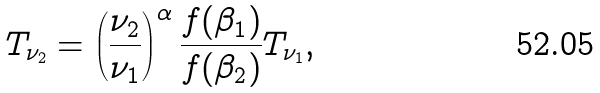Convert formula to latex. <formula><loc_0><loc_0><loc_500><loc_500>T _ { \nu _ { 2 } } = \left ( \frac { \nu _ { 2 } } { \nu _ { 1 } } \right ) ^ { \alpha } \frac { f ( \beta _ { 1 } ) } { f ( \beta _ { 2 } ) } T _ { \nu _ { 1 } } ,</formula> 